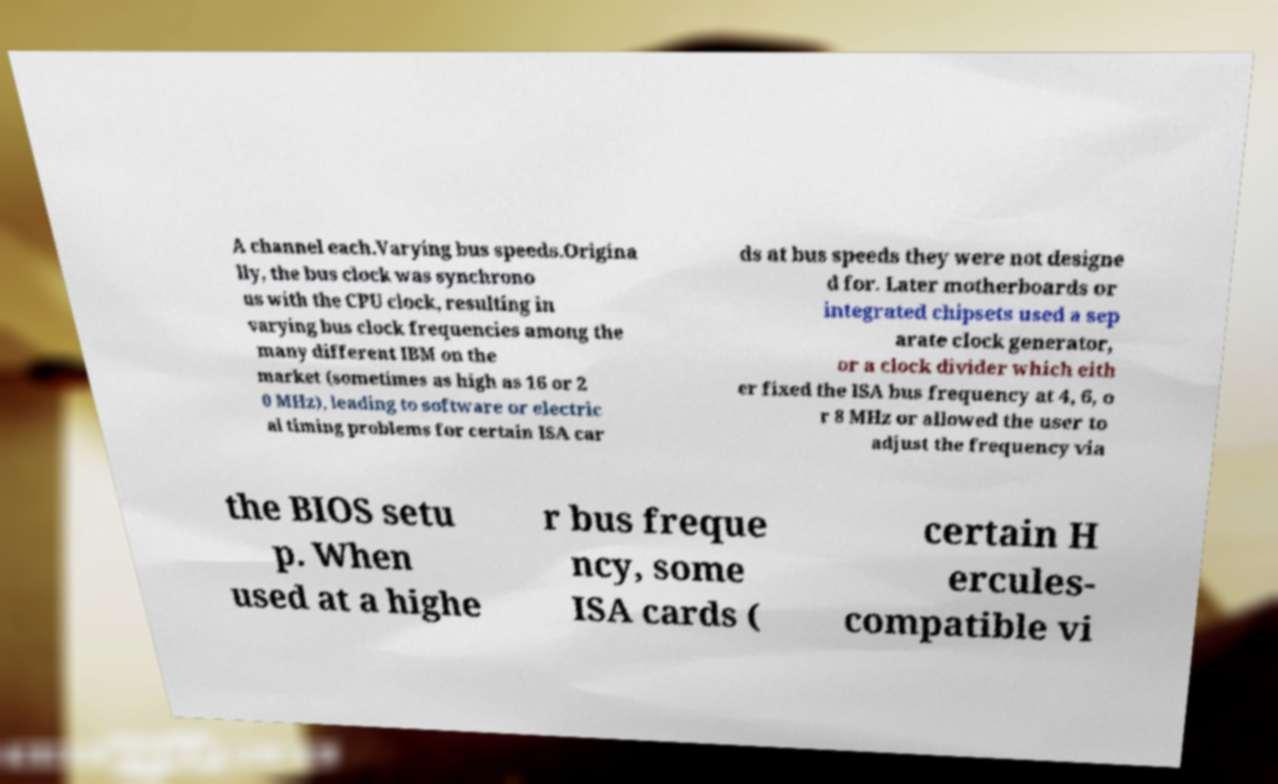What messages or text are displayed in this image? I need them in a readable, typed format. A channel each.Varying bus speeds.Origina lly, the bus clock was synchrono us with the CPU clock, resulting in varying bus clock frequencies among the many different IBM on the market (sometimes as high as 16 or 2 0 MHz), leading to software or electric al timing problems for certain ISA car ds at bus speeds they were not designe d for. Later motherboards or integrated chipsets used a sep arate clock generator, or a clock divider which eith er fixed the ISA bus frequency at 4, 6, o r 8 MHz or allowed the user to adjust the frequency via the BIOS setu p. When used at a highe r bus freque ncy, some ISA cards ( certain H ercules- compatible vi 